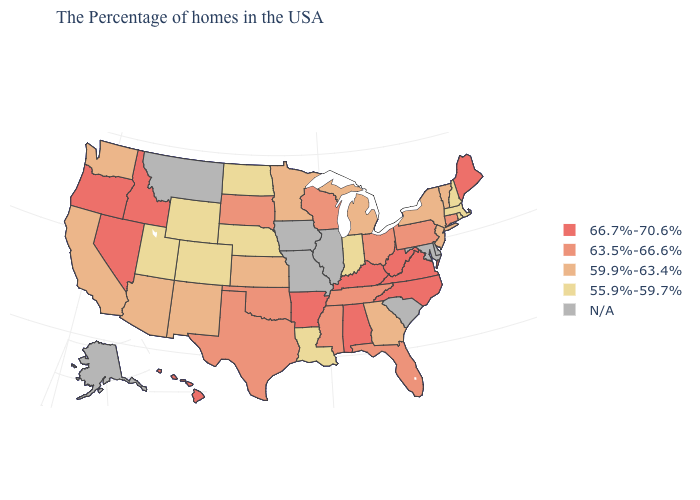Name the states that have a value in the range 55.9%-59.7%?
Keep it brief. Massachusetts, Rhode Island, New Hampshire, Indiana, Louisiana, Nebraska, North Dakota, Wyoming, Colorado, Utah. What is the value of Georgia?
Write a very short answer. 59.9%-63.4%. What is the value of Mississippi?
Concise answer only. 63.5%-66.6%. Among the states that border Arizona , which have the highest value?
Give a very brief answer. Nevada. Does the first symbol in the legend represent the smallest category?
Be succinct. No. Which states have the highest value in the USA?
Concise answer only. Maine, Virginia, North Carolina, West Virginia, Kentucky, Alabama, Arkansas, Idaho, Nevada, Oregon, Hawaii. Does Alabama have the highest value in the USA?
Be succinct. Yes. What is the value of Illinois?
Short answer required. N/A. Does California have the lowest value in the West?
Give a very brief answer. No. What is the value of New Jersey?
Quick response, please. 59.9%-63.4%. Which states have the lowest value in the Northeast?
Quick response, please. Massachusetts, Rhode Island, New Hampshire. Does the map have missing data?
Concise answer only. Yes. How many symbols are there in the legend?
Write a very short answer. 5. 